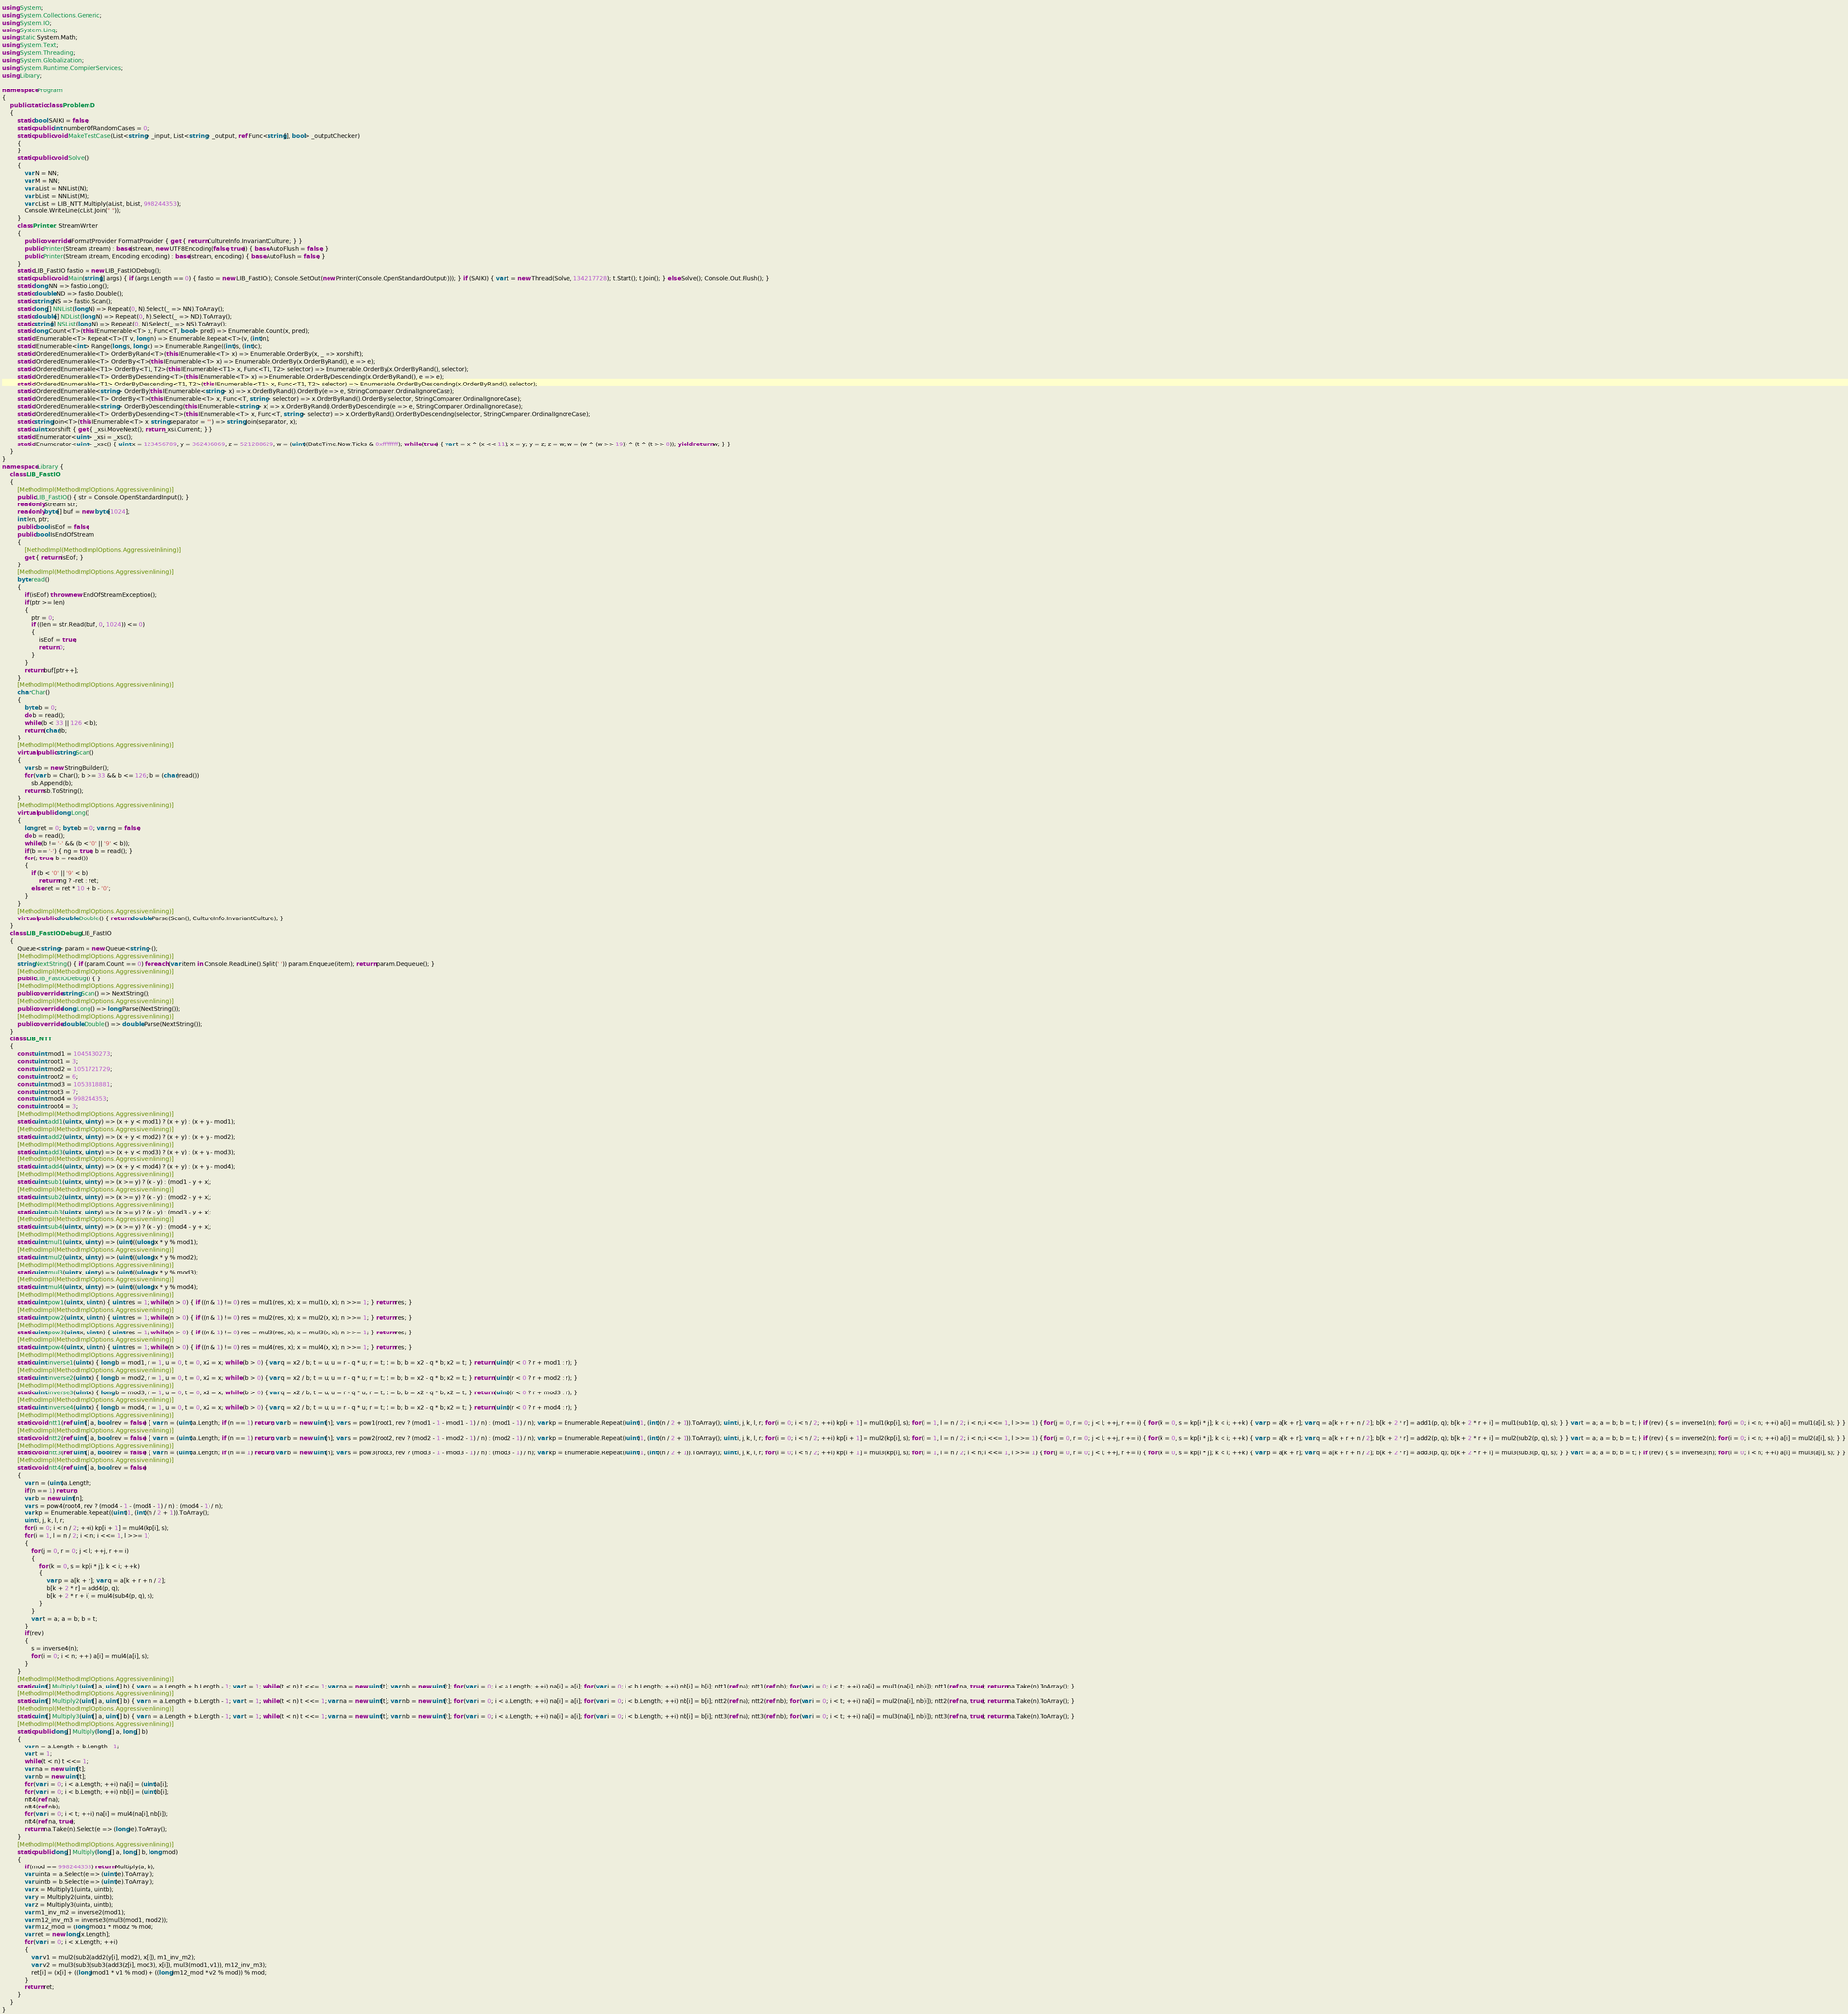<code> <loc_0><loc_0><loc_500><loc_500><_C#_>using System;
using System.Collections.Generic;
using System.IO;
using System.Linq;
using static System.Math;
using System.Text;
using System.Threading;
using System.Globalization;
using System.Runtime.CompilerServices;
using Library;

namespace Program
{
    public static class ProblemD
    {
        static bool SAIKI = false;
        static public int numberOfRandomCases = 0;
        static public void MakeTestCase(List<string> _input, List<string> _output, ref Func<string[], bool> _outputChecker)
        {
        }
        static public void Solve()
        {
            var N = NN;
            var M = NN;
            var aList = NNList(N);
            var bList = NNList(M);
            var cList = LIB_NTT.Multiply(aList, bList, 998244353);
            Console.WriteLine(cList.Join(" "));
        }
        class Printer : StreamWriter
        {
            public override IFormatProvider FormatProvider { get { return CultureInfo.InvariantCulture; } }
            public Printer(Stream stream) : base(stream, new UTF8Encoding(false, true)) { base.AutoFlush = false; }
            public Printer(Stream stream, Encoding encoding) : base(stream, encoding) { base.AutoFlush = false; }
        }
        static LIB_FastIO fastio = new LIB_FastIODebug();
        static public void Main(string[] args) { if (args.Length == 0) { fastio = new LIB_FastIO(); Console.SetOut(new Printer(Console.OpenStandardOutput())); } if (SAIKI) { var t = new Thread(Solve, 134217728); t.Start(); t.Join(); } else Solve(); Console.Out.Flush(); }
        static long NN => fastio.Long();
        static double ND => fastio.Double();
        static string NS => fastio.Scan();
        static long[] NNList(long N) => Repeat(0, N).Select(_ => NN).ToArray();
        static double[] NDList(long N) => Repeat(0, N).Select(_ => ND).ToArray();
        static string[] NSList(long N) => Repeat(0, N).Select(_ => NS).ToArray();
        static long Count<T>(this IEnumerable<T> x, Func<T, bool> pred) => Enumerable.Count(x, pred);
        static IEnumerable<T> Repeat<T>(T v, long n) => Enumerable.Repeat<T>(v, (int)n);
        static IEnumerable<int> Range(long s, long c) => Enumerable.Range((int)s, (int)c);
        static IOrderedEnumerable<T> OrderByRand<T>(this IEnumerable<T> x) => Enumerable.OrderBy(x, _ => xorshift);
        static IOrderedEnumerable<T> OrderBy<T>(this IEnumerable<T> x) => Enumerable.OrderBy(x.OrderByRand(), e => e);
        static IOrderedEnumerable<T1> OrderBy<T1, T2>(this IEnumerable<T1> x, Func<T1, T2> selector) => Enumerable.OrderBy(x.OrderByRand(), selector);
        static IOrderedEnumerable<T> OrderByDescending<T>(this IEnumerable<T> x) => Enumerable.OrderByDescending(x.OrderByRand(), e => e);
        static IOrderedEnumerable<T1> OrderByDescending<T1, T2>(this IEnumerable<T1> x, Func<T1, T2> selector) => Enumerable.OrderByDescending(x.OrderByRand(), selector);
        static IOrderedEnumerable<string> OrderBy(this IEnumerable<string> x) => x.OrderByRand().OrderBy(e => e, StringComparer.OrdinalIgnoreCase);
        static IOrderedEnumerable<T> OrderBy<T>(this IEnumerable<T> x, Func<T, string> selector) => x.OrderByRand().OrderBy(selector, StringComparer.OrdinalIgnoreCase);
        static IOrderedEnumerable<string> OrderByDescending(this IEnumerable<string> x) => x.OrderByRand().OrderByDescending(e => e, StringComparer.OrdinalIgnoreCase);
        static IOrderedEnumerable<T> OrderByDescending<T>(this IEnumerable<T> x, Func<T, string> selector) => x.OrderByRand().OrderByDescending(selector, StringComparer.OrdinalIgnoreCase);
        static string Join<T>(this IEnumerable<T> x, string separator = "") => string.Join(separator, x);
        static uint xorshift { get { _xsi.MoveNext(); return _xsi.Current; } }
        static IEnumerator<uint> _xsi = _xsc();
        static IEnumerator<uint> _xsc() { uint x = 123456789, y = 362436069, z = 521288629, w = (uint)(DateTime.Now.Ticks & 0xffffffff); while (true) { var t = x ^ (x << 11); x = y; y = z; z = w; w = (w ^ (w >> 19)) ^ (t ^ (t >> 8)); yield return w; } }
    }
}
namespace Library {
    class LIB_FastIO
    {
        [MethodImpl(MethodImplOptions.AggressiveInlining)]
        public LIB_FastIO() { str = Console.OpenStandardInput(); }
        readonly Stream str;
        readonly byte[] buf = new byte[1024];
        int len, ptr;
        public bool isEof = false;
        public bool IsEndOfStream
        {
            [MethodImpl(MethodImplOptions.AggressiveInlining)]
            get { return isEof; }
        }
        [MethodImpl(MethodImplOptions.AggressiveInlining)]
        byte read()
        {
            if (isEof) throw new EndOfStreamException();
            if (ptr >= len)
            {
                ptr = 0;
                if ((len = str.Read(buf, 0, 1024)) <= 0)
                {
                    isEof = true;
                    return 0;
                }
            }
            return buf[ptr++];
        }
        [MethodImpl(MethodImplOptions.AggressiveInlining)]
        char Char()
        {
            byte b = 0;
            do b = read();
            while (b < 33 || 126 < b);
            return (char)b;
        }
        [MethodImpl(MethodImplOptions.AggressiveInlining)]
        virtual public string Scan()
        {
            var sb = new StringBuilder();
            for (var b = Char(); b >= 33 && b <= 126; b = (char)read())
                sb.Append(b);
            return sb.ToString();
        }
        [MethodImpl(MethodImplOptions.AggressiveInlining)]
        virtual public long Long()
        {
            long ret = 0; byte b = 0; var ng = false;
            do b = read();
            while (b != '-' && (b < '0' || '9' < b));
            if (b == '-') { ng = true; b = read(); }
            for (; true; b = read())
            {
                if (b < '0' || '9' < b)
                    return ng ? -ret : ret;
                else ret = ret * 10 + b - '0';
            }
        }
        [MethodImpl(MethodImplOptions.AggressiveInlining)]
        virtual public double Double() { return double.Parse(Scan(), CultureInfo.InvariantCulture); }
    }
    class LIB_FastIODebug : LIB_FastIO
    {
        Queue<string> param = new Queue<string>();
        [MethodImpl(MethodImplOptions.AggressiveInlining)]
        string NextString() { if (param.Count == 0) foreach (var item in Console.ReadLine().Split(' ')) param.Enqueue(item); return param.Dequeue(); }
        [MethodImpl(MethodImplOptions.AggressiveInlining)]
        public LIB_FastIODebug() { }
        [MethodImpl(MethodImplOptions.AggressiveInlining)]
        public override string Scan() => NextString();
        [MethodImpl(MethodImplOptions.AggressiveInlining)]
        public override long Long() => long.Parse(NextString());
        [MethodImpl(MethodImplOptions.AggressiveInlining)]
        public override double Double() => double.Parse(NextString());
    }
    class LIB_NTT
    {
        const uint mod1 = 1045430273;
        const uint root1 = 3;
        const uint mod2 = 1051721729;
        const uint root2 = 6;
        const uint mod3 = 1053818881;
        const uint root3 = 7;
        const uint mod4 = 998244353;
        const uint root4 = 3;
        [MethodImpl(MethodImplOptions.AggressiveInlining)]
        static uint add1(uint x, uint y) => (x + y < mod1) ? (x + y) : (x + y - mod1);
        [MethodImpl(MethodImplOptions.AggressiveInlining)]
        static uint add2(uint x, uint y) => (x + y < mod2) ? (x + y) : (x + y - mod2);
        [MethodImpl(MethodImplOptions.AggressiveInlining)]
        static uint add3(uint x, uint y) => (x + y < mod3) ? (x + y) : (x + y - mod3);
        [MethodImpl(MethodImplOptions.AggressiveInlining)]
        static uint add4(uint x, uint y) => (x + y < mod4) ? (x + y) : (x + y - mod4);
        [MethodImpl(MethodImplOptions.AggressiveInlining)]
        static uint sub1(uint x, uint y) => (x >= y) ? (x - y) : (mod1 - y + x);
        [MethodImpl(MethodImplOptions.AggressiveInlining)]
        static uint sub2(uint x, uint y) => (x >= y) ? (x - y) : (mod2 - y + x);
        [MethodImpl(MethodImplOptions.AggressiveInlining)]
        static uint sub3(uint x, uint y) => (x >= y) ? (x - y) : (mod3 - y + x);
        [MethodImpl(MethodImplOptions.AggressiveInlining)]
        static uint sub4(uint x, uint y) => (x >= y) ? (x - y) : (mod4 - y + x);
        [MethodImpl(MethodImplOptions.AggressiveInlining)]
        static uint mul1(uint x, uint y) => (uint)((ulong)x * y % mod1);
        [MethodImpl(MethodImplOptions.AggressiveInlining)]
        static uint mul2(uint x, uint y) => (uint)((ulong)x * y % mod2);
        [MethodImpl(MethodImplOptions.AggressiveInlining)]
        static uint mul3(uint x, uint y) => (uint)((ulong)x * y % mod3);
        [MethodImpl(MethodImplOptions.AggressiveInlining)]
        static uint mul4(uint x, uint y) => (uint)((ulong)x * y % mod4);
        [MethodImpl(MethodImplOptions.AggressiveInlining)]
        static uint pow1(uint x, uint n) { uint res = 1; while (n > 0) { if ((n & 1) != 0) res = mul1(res, x); x = mul1(x, x); n >>= 1; } return res; }
        [MethodImpl(MethodImplOptions.AggressiveInlining)]
        static uint pow2(uint x, uint n) { uint res = 1; while (n > 0) { if ((n & 1) != 0) res = mul2(res, x); x = mul2(x, x); n >>= 1; } return res; }
        [MethodImpl(MethodImplOptions.AggressiveInlining)]
        static uint pow3(uint x, uint n) { uint res = 1; while (n > 0) { if ((n & 1) != 0) res = mul3(res, x); x = mul3(x, x); n >>= 1; } return res; }
        [MethodImpl(MethodImplOptions.AggressiveInlining)]
        static uint pow4(uint x, uint n) { uint res = 1; while (n > 0) { if ((n & 1) != 0) res = mul4(res, x); x = mul4(x, x); n >>= 1; } return res; }
        [MethodImpl(MethodImplOptions.AggressiveInlining)]
        static uint inverse1(uint x) { long b = mod1, r = 1, u = 0, t = 0, x2 = x; while (b > 0) { var q = x2 / b; t = u; u = r - q * u; r = t; t = b; b = x2 - q * b; x2 = t; } return (uint)(r < 0 ? r + mod1 : r); }
        [MethodImpl(MethodImplOptions.AggressiveInlining)]
        static uint inverse2(uint x) { long b = mod2, r = 1, u = 0, t = 0, x2 = x; while (b > 0) { var q = x2 / b; t = u; u = r - q * u; r = t; t = b; b = x2 - q * b; x2 = t; } return (uint)(r < 0 ? r + mod2 : r); }
        [MethodImpl(MethodImplOptions.AggressiveInlining)]
        static uint inverse3(uint x) { long b = mod3, r = 1, u = 0, t = 0, x2 = x; while (b > 0) { var q = x2 / b; t = u; u = r - q * u; r = t; t = b; b = x2 - q * b; x2 = t; } return (uint)(r < 0 ? r + mod3 : r); }
        [MethodImpl(MethodImplOptions.AggressiveInlining)]
        static uint inverse4(uint x) { long b = mod4, r = 1, u = 0, t = 0, x2 = x; while (b > 0) { var q = x2 / b; t = u; u = r - q * u; r = t; t = b; b = x2 - q * b; x2 = t; } return (uint)(r < 0 ? r + mod4 : r); }
        [MethodImpl(MethodImplOptions.AggressiveInlining)]
        static void ntt1(ref uint[] a, bool rev = false) { var n = (uint)a.Length; if (n == 1) return; var b = new uint[n]; var s = pow1(root1, rev ? (mod1 - 1 - (mod1 - 1) / n) : (mod1 - 1) / n); var kp = Enumerable.Repeat((uint)1, (int)(n / 2 + 1)).ToArray(); uint i, j, k, l, r; for (i = 0; i < n / 2; ++i) kp[i + 1] = mul1(kp[i], s); for (i = 1, l = n / 2; i < n; i <<= 1, l >>= 1) { for (j = 0, r = 0; j < l; ++j, r += i) { for (k = 0, s = kp[i * j]; k < i; ++k) { var p = a[k + r]; var q = a[k + r + n / 2]; b[k + 2 * r] = add1(p, q); b[k + 2 * r + i] = mul1(sub1(p, q), s); } } var t = a; a = b; b = t; } if (rev) { s = inverse1(n); for (i = 0; i < n; ++i) a[i] = mul1(a[i], s); } }
        [MethodImpl(MethodImplOptions.AggressiveInlining)]
        static void ntt2(ref uint[] a, bool rev = false) { var n = (uint)a.Length; if (n == 1) return; var b = new uint[n]; var s = pow2(root2, rev ? (mod2 - 1 - (mod2 - 1) / n) : (mod2 - 1) / n); var kp = Enumerable.Repeat((uint)1, (int)(n / 2 + 1)).ToArray(); uint i, j, k, l, r; for (i = 0; i < n / 2; ++i) kp[i + 1] = mul2(kp[i], s); for (i = 1, l = n / 2; i < n; i <<= 1, l >>= 1) { for (j = 0, r = 0; j < l; ++j, r += i) { for (k = 0, s = kp[i * j]; k < i; ++k) { var p = a[k + r]; var q = a[k + r + n / 2]; b[k + 2 * r] = add2(p, q); b[k + 2 * r + i] = mul2(sub2(p, q), s); } } var t = a; a = b; b = t; } if (rev) { s = inverse2(n); for (i = 0; i < n; ++i) a[i] = mul2(a[i], s); } }
        [MethodImpl(MethodImplOptions.AggressiveInlining)]
        static void ntt3(ref uint[] a, bool rev = false) { var n = (uint)a.Length; if (n == 1) return; var b = new uint[n]; var s = pow3(root3, rev ? (mod3 - 1 - (mod3 - 1) / n) : (mod3 - 1) / n); var kp = Enumerable.Repeat((uint)1, (int)(n / 2 + 1)).ToArray(); uint i, j, k, l, r; for (i = 0; i < n / 2; ++i) kp[i + 1] = mul3(kp[i], s); for (i = 1, l = n / 2; i < n; i <<= 1, l >>= 1) { for (j = 0, r = 0; j < l; ++j, r += i) { for (k = 0, s = kp[i * j]; k < i; ++k) { var p = a[k + r]; var q = a[k + r + n / 2]; b[k + 2 * r] = add3(p, q); b[k + 2 * r + i] = mul3(sub3(p, q), s); } } var t = a; a = b; b = t; } if (rev) { s = inverse3(n); for (i = 0; i < n; ++i) a[i] = mul3(a[i], s); } }
        [MethodImpl(MethodImplOptions.AggressiveInlining)]
        static void ntt4(ref uint[] a, bool rev = false)
        {
            var n = (uint)a.Length;
            if (n == 1) return;
            var b = new uint[n];
            var s = pow4(root4, rev ? (mod4 - 1 - (mod4 - 1) / n) : (mod4 - 1) / n);
            var kp = Enumerable.Repeat((uint)1, (int)(n / 2 + 1)).ToArray();
            uint i, j, k, l, r;
            for (i = 0; i < n / 2; ++i) kp[i + 1] = mul4(kp[i], s);
            for (i = 1, l = n / 2; i < n; i <<= 1, l >>= 1)
            {
                for (j = 0, r = 0; j < l; ++j, r += i)
                {
                    for (k = 0, s = kp[i * j]; k < i; ++k)
                    {
                        var p = a[k + r]; var q = a[k + r + n / 2];
                        b[k + 2 * r] = add4(p, q);
                        b[k + 2 * r + i] = mul4(sub4(p, q), s);
                    }
                }
                var t = a; a = b; b = t;
            }
            if (rev)
            {
                s = inverse4(n);
                for (i = 0; i < n; ++i) a[i] = mul4(a[i], s);
            }
        }
        [MethodImpl(MethodImplOptions.AggressiveInlining)]
        static uint[] Multiply1(uint[] a, uint[] b) { var n = a.Length + b.Length - 1; var t = 1; while (t < n) t <<= 1; var na = new uint[t]; var nb = new uint[t]; for (var i = 0; i < a.Length; ++i) na[i] = a[i]; for (var i = 0; i < b.Length; ++i) nb[i] = b[i]; ntt1(ref na); ntt1(ref nb); for (var i = 0; i < t; ++i) na[i] = mul1(na[i], nb[i]); ntt1(ref na, true); return na.Take(n).ToArray(); }
        [MethodImpl(MethodImplOptions.AggressiveInlining)]
        static uint[] Multiply2(uint[] a, uint[] b) { var n = a.Length + b.Length - 1; var t = 1; while (t < n) t <<= 1; var na = new uint[t]; var nb = new uint[t]; for (var i = 0; i < a.Length; ++i) na[i] = a[i]; for (var i = 0; i < b.Length; ++i) nb[i] = b[i]; ntt2(ref na); ntt2(ref nb); for (var i = 0; i < t; ++i) na[i] = mul2(na[i], nb[i]); ntt2(ref na, true); return na.Take(n).ToArray(); }
        [MethodImpl(MethodImplOptions.AggressiveInlining)]
        static uint[] Multiply3(uint[] a, uint[] b) { var n = a.Length + b.Length - 1; var t = 1; while (t < n) t <<= 1; var na = new uint[t]; var nb = new uint[t]; for (var i = 0; i < a.Length; ++i) na[i] = a[i]; for (var i = 0; i < b.Length; ++i) nb[i] = b[i]; ntt3(ref na); ntt3(ref nb); for (var i = 0; i < t; ++i) na[i] = mul3(na[i], nb[i]); ntt3(ref na, true); return na.Take(n).ToArray(); }
        [MethodImpl(MethodImplOptions.AggressiveInlining)]
        static public long[] Multiply(long[] a, long[] b)
        {
            var n = a.Length + b.Length - 1;
            var t = 1;
            while (t < n) t <<= 1;
            var na = new uint[t];
            var nb = new uint[t];
            for (var i = 0; i < a.Length; ++i) na[i] = (uint)a[i];
            for (var i = 0; i < b.Length; ++i) nb[i] = (uint)b[i];
            ntt4(ref na);
            ntt4(ref nb);
            for (var i = 0; i < t; ++i) na[i] = mul4(na[i], nb[i]);
            ntt4(ref na, true);
            return na.Take(n).Select(e => (long)e).ToArray();
        }
        [MethodImpl(MethodImplOptions.AggressiveInlining)]
        static public long[] Multiply(long[] a, long[] b, long mod)
        {
            if (mod == 998244353) return Multiply(a, b);
            var uinta = a.Select(e => (uint)e).ToArray();
            var uintb = b.Select(e => (uint)e).ToArray();
            var x = Multiply1(uinta, uintb);
            var y = Multiply2(uinta, uintb);
            var z = Multiply3(uinta, uintb);
            var m1_inv_m2 = inverse2(mod1);
            var m12_inv_m3 = inverse3(mul3(mod1, mod2));
            var m12_mod = (long)mod1 * mod2 % mod;
            var ret = new long[x.Length];
            for (var i = 0; i < x.Length; ++i)
            {
                var v1 = mul2(sub2(add2(y[i], mod2), x[i]), m1_inv_m2);
                var v2 = mul3(sub3(sub3(add3(z[i], mod3), x[i]), mul3(mod1, v1)), m12_inv_m3);
                ret[i] = (x[i] + ((long)mod1 * v1 % mod) + ((long)m12_mod * v2 % mod)) % mod;
            }
            return ret;
        }
    }
}
</code> 